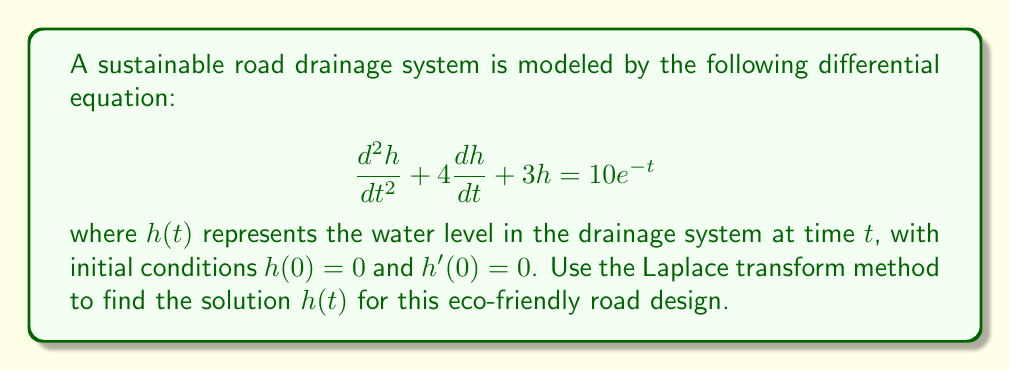Can you solve this math problem? Let's solve this step-by-step using the Laplace transform method:

1) Take the Laplace transform of both sides of the equation:
   $$\mathcal{L}\{h''(t) + 4h'(t) + 3h(t)\} = \mathcal{L}\{10e^{-t}\}$$

2) Using Laplace transform properties:
   $$[s^2H(s) - sh(0) - h'(0)] + 4[sH(s) - h(0)] + 3H(s) = \frac{10}{s+1}$$

3) Substitute the initial conditions $h(0) = 0$ and $h'(0) = 0$:
   $$s^2H(s) + 4sH(s) + 3H(s) = \frac{10}{s+1}$$

4) Factor out $H(s)$:
   $$H(s)(s^2 + 4s + 3) = \frac{10}{s+1}$$

5) Solve for $H(s)$:
   $$H(s) = \frac{10}{(s+1)(s^2 + 4s + 3)}$$

6) Factor the denominator:
   $$H(s) = \frac{10}{(s+1)(s+1)(s+3)}$$

7) Perform partial fraction decomposition:
   $$H(s) = \frac{A}{s+1} + \frac{B}{(s+1)^2} + \frac{C}{s+3}$$

8) Solve for $A$, $B$, and $C$:
   $A = 5$, $B = -5$, $C = -5$

9) Rewrite $H(s)$:
   $$H(s) = \frac{5}{s+1} - \frac{5}{(s+1)^2} - \frac{5}{s+3}$$

10) Take the inverse Laplace transform:
    $$h(t) = 5e^{-t} - 5te^{-t} - 5e^{-3t}$$

This solution represents the water level in the drainage system over time, considering the eco-friendly design parameters.
Answer: $h(t) = 5e^{-t} - 5te^{-t} - 5e^{-3t}$ 